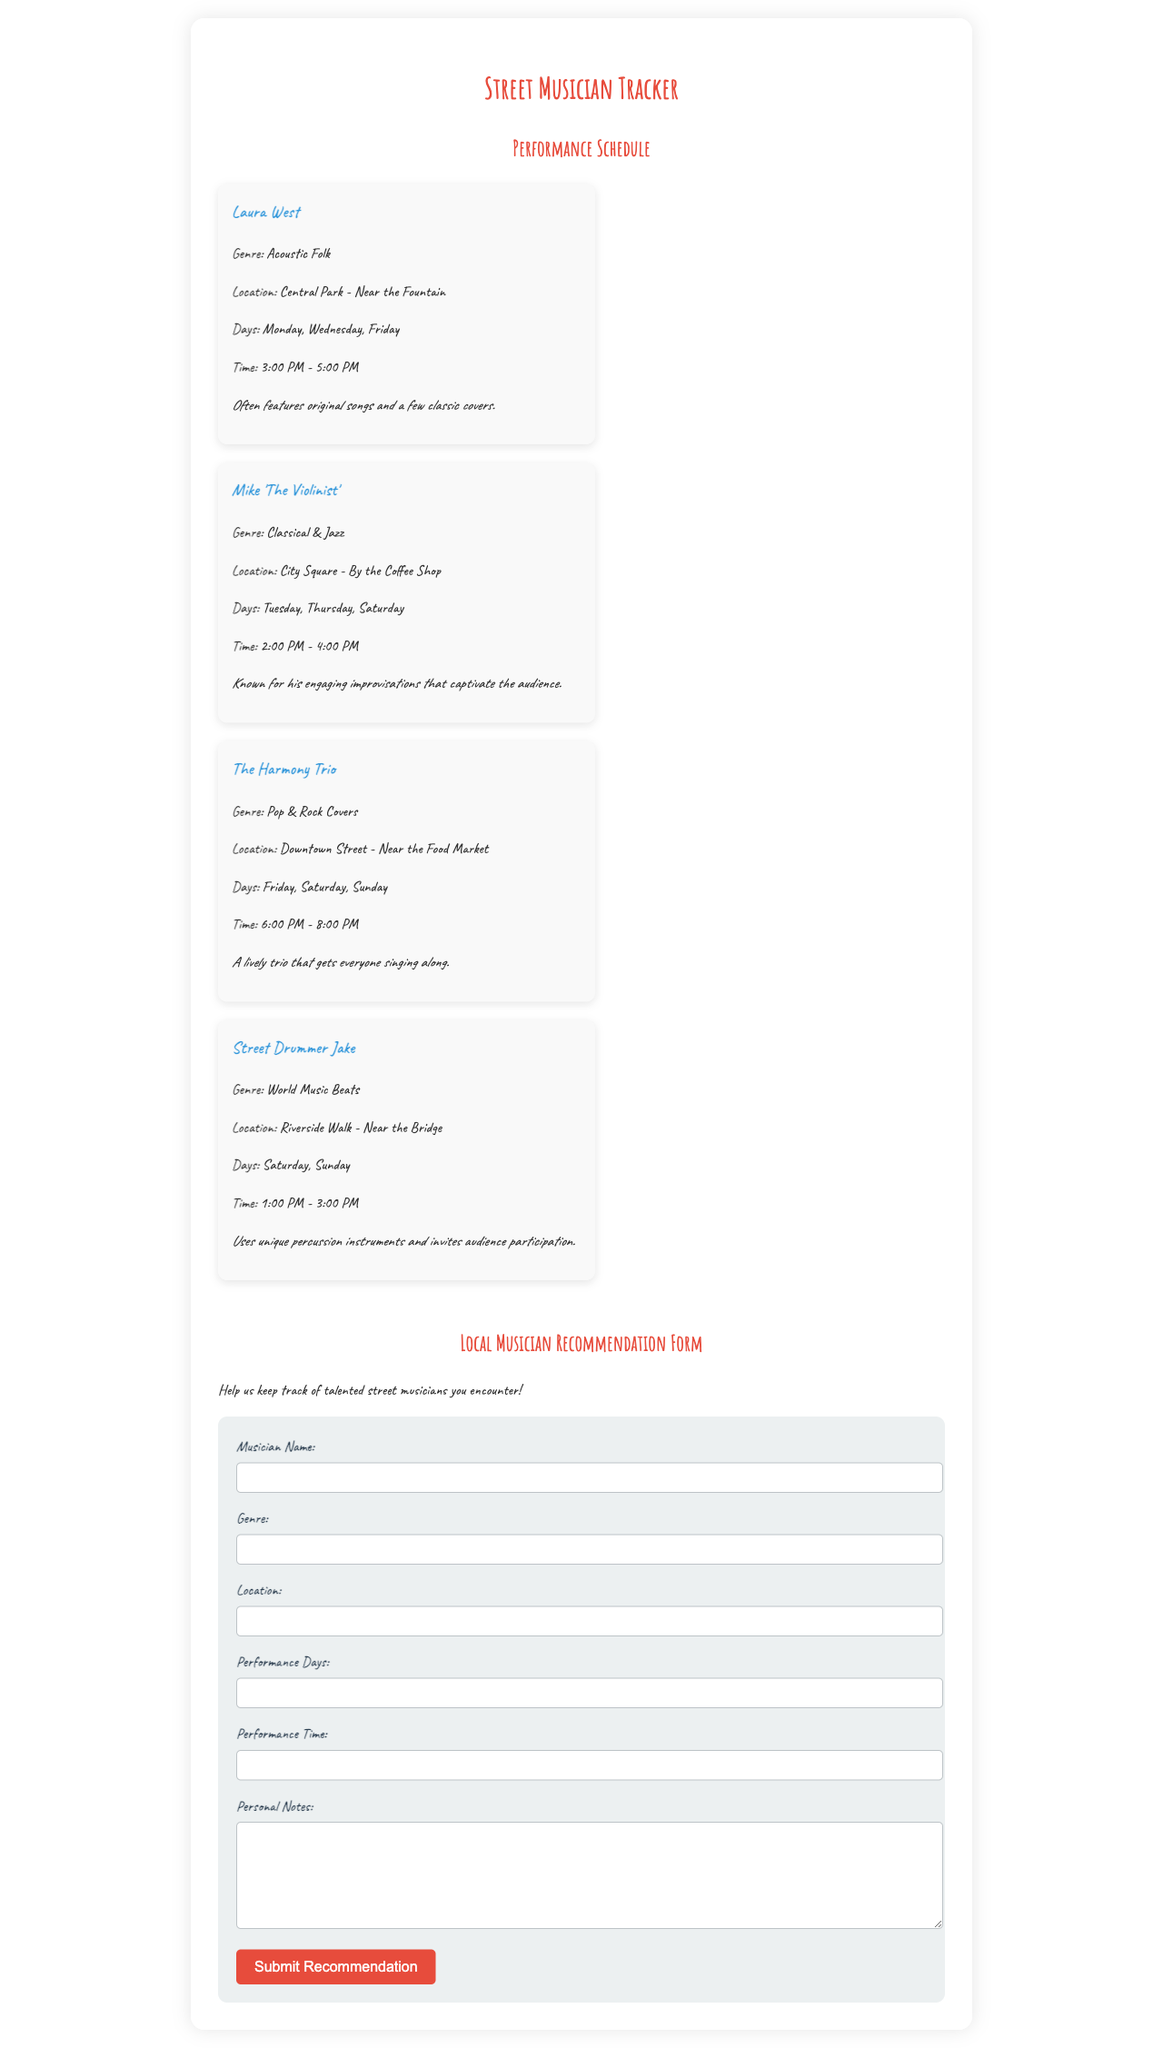What is the genre of Laura West? The genre of Laura West is mentioned in the schedule as Acoustic Folk.
Answer: Acoustic Folk Where does Mike 'The Violinist' perform? The location for Mike 'The Violinist' is specified as City Square - By the Coffee Shop in the document.
Answer: City Square - By the Coffee Shop On which days does The Harmony Trio perform? The performance days for The Harmony Trio are listed as Friday, Saturday, and Sunday.
Answer: Friday, Saturday, Sunday What time does Street Drummer Jake perform? The document states that Street Drummer Jake performs from 1:00 PM to 3:00 PM.
Answer: 1:00 PM - 3:00 PM Which musician has a performance on Tuesday? The document indicates that Mike 'The Violinist' performs on Tuesday.
Answer: Mike 'The Violinist' How many musicians are featured in the schedule? The total number of musicians listed in the performance schedule can be counted from the document.
Answer: Four What type of form is included in the document? The document includes a recommendation form for local musicians.
Answer: Recommendation form What additional information can you provide when submitting a musician? The form allows for personal notes about the musician being submitted.
Answer: Personal notes 